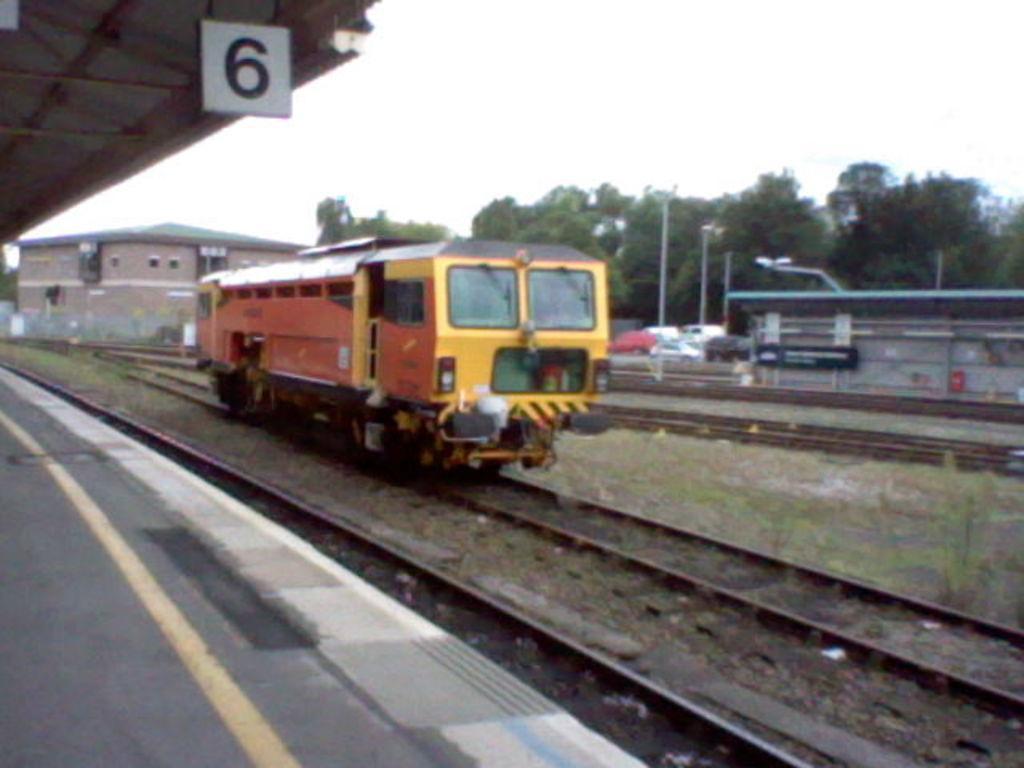Can you describe this image briefly? On the left side of the image there is a platform. Beside the platform on the ground there are train tracks with an engine. Behind that there is a roof with few objects. In the background there is a building, trees, poles and also there are vehicles. In the top left corner of the image there is a roof and a number. 